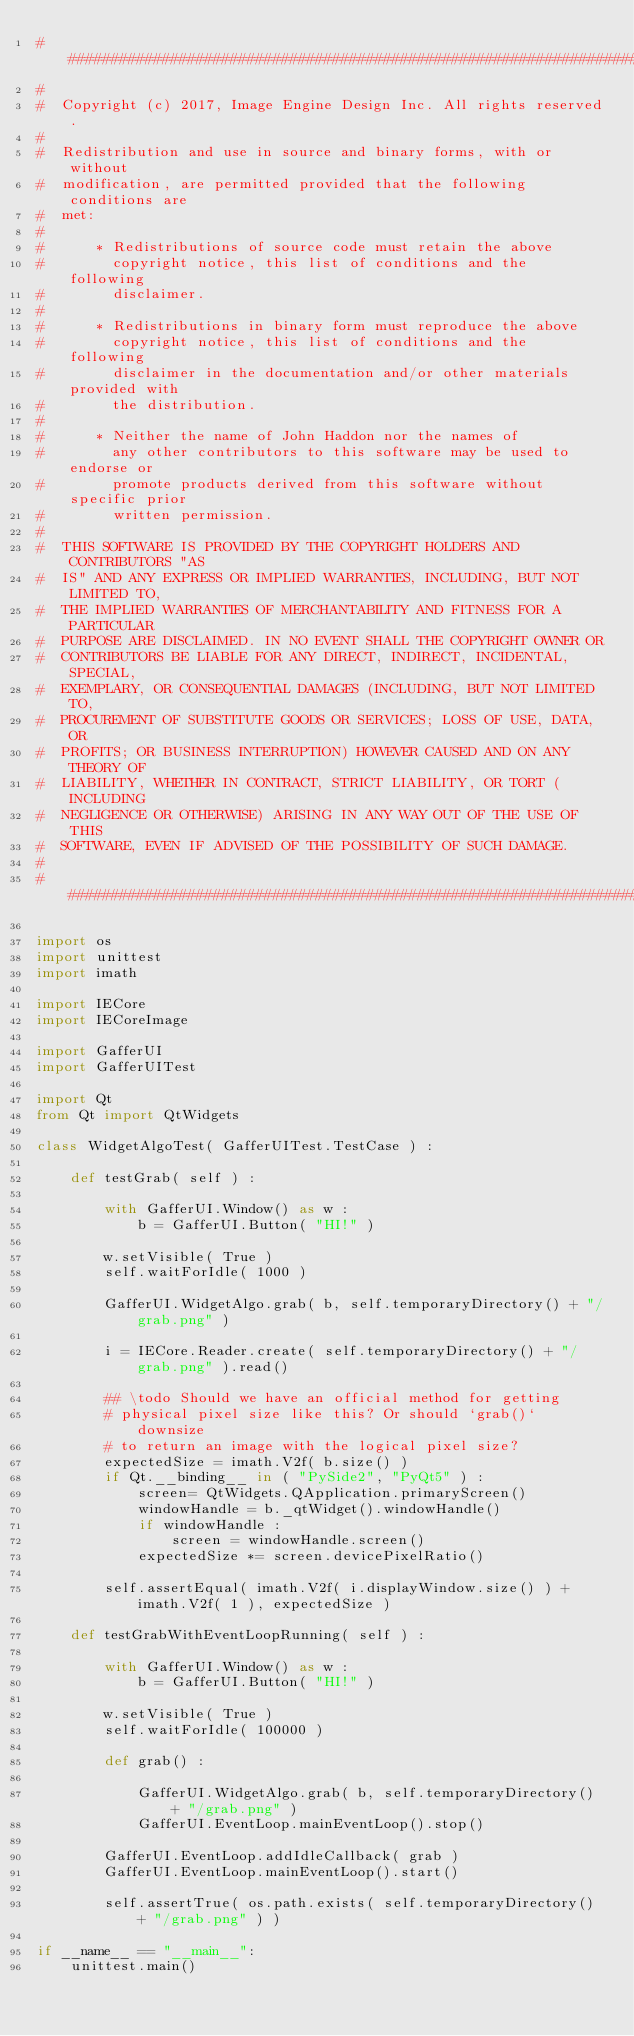Convert code to text. <code><loc_0><loc_0><loc_500><loc_500><_Python_>##########################################################################
#
#  Copyright (c) 2017, Image Engine Design Inc. All rights reserved.
#
#  Redistribution and use in source and binary forms, with or without
#  modification, are permitted provided that the following conditions are
#  met:
#
#      * Redistributions of source code must retain the above
#        copyright notice, this list of conditions and the following
#        disclaimer.
#
#      * Redistributions in binary form must reproduce the above
#        copyright notice, this list of conditions and the following
#        disclaimer in the documentation and/or other materials provided with
#        the distribution.
#
#      * Neither the name of John Haddon nor the names of
#        any other contributors to this software may be used to endorse or
#        promote products derived from this software without specific prior
#        written permission.
#
#  THIS SOFTWARE IS PROVIDED BY THE COPYRIGHT HOLDERS AND CONTRIBUTORS "AS
#  IS" AND ANY EXPRESS OR IMPLIED WARRANTIES, INCLUDING, BUT NOT LIMITED TO,
#  THE IMPLIED WARRANTIES OF MERCHANTABILITY AND FITNESS FOR A PARTICULAR
#  PURPOSE ARE DISCLAIMED. IN NO EVENT SHALL THE COPYRIGHT OWNER OR
#  CONTRIBUTORS BE LIABLE FOR ANY DIRECT, INDIRECT, INCIDENTAL, SPECIAL,
#  EXEMPLARY, OR CONSEQUENTIAL DAMAGES (INCLUDING, BUT NOT LIMITED TO,
#  PROCUREMENT OF SUBSTITUTE GOODS OR SERVICES; LOSS OF USE, DATA, OR
#  PROFITS; OR BUSINESS INTERRUPTION) HOWEVER CAUSED AND ON ANY THEORY OF
#  LIABILITY, WHETHER IN CONTRACT, STRICT LIABILITY, OR TORT (INCLUDING
#  NEGLIGENCE OR OTHERWISE) ARISING IN ANY WAY OUT OF THE USE OF THIS
#  SOFTWARE, EVEN IF ADVISED OF THE POSSIBILITY OF SUCH DAMAGE.
#
##########################################################################

import os
import unittest
import imath

import IECore
import IECoreImage

import GafferUI
import GafferUITest

import Qt
from Qt import QtWidgets

class WidgetAlgoTest( GafferUITest.TestCase ) :

	def testGrab( self ) :

		with GafferUI.Window() as w :
			b = GafferUI.Button( "HI!" )

		w.setVisible( True )
		self.waitForIdle( 1000 )

		GafferUI.WidgetAlgo.grab( b, self.temporaryDirectory() + "/grab.png" )

		i = IECore.Reader.create( self.temporaryDirectory() + "/grab.png" ).read()

		## \todo Should we have an official method for getting
		# physical pixel size like this? Or should `grab()` downsize
		# to return an image with the logical pixel size?
		expectedSize = imath.V2f( b.size() )
		if Qt.__binding__ in ( "PySide2", "PyQt5" ) :
			screen= QtWidgets.QApplication.primaryScreen()
			windowHandle = b._qtWidget().windowHandle()
			if windowHandle :
				screen = windowHandle.screen()
			expectedSize *= screen.devicePixelRatio()

		self.assertEqual( imath.V2f( i.displayWindow.size() ) + imath.V2f( 1 ), expectedSize )

	def testGrabWithEventLoopRunning( self ) :

		with GafferUI.Window() as w :
			b = GafferUI.Button( "HI!" )

		w.setVisible( True )
		self.waitForIdle( 100000 )

		def grab() :

			GafferUI.WidgetAlgo.grab( b, self.temporaryDirectory() + "/grab.png" )
			GafferUI.EventLoop.mainEventLoop().stop()

		GafferUI.EventLoop.addIdleCallback( grab )
		GafferUI.EventLoop.mainEventLoop().start()

		self.assertTrue( os.path.exists( self.temporaryDirectory() + "/grab.png" ) )

if __name__ == "__main__":
	unittest.main()
</code> 